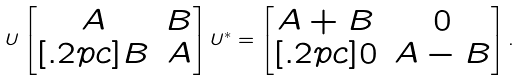<formula> <loc_0><loc_0><loc_500><loc_500>U \begin{bmatrix} A & B \\ [ . 2 p c ] B & A \end{bmatrix} U ^ { * } = \begin{bmatrix} A + B & 0 \\ [ . 2 p c ] 0 & A - B \end{bmatrix} .</formula> 